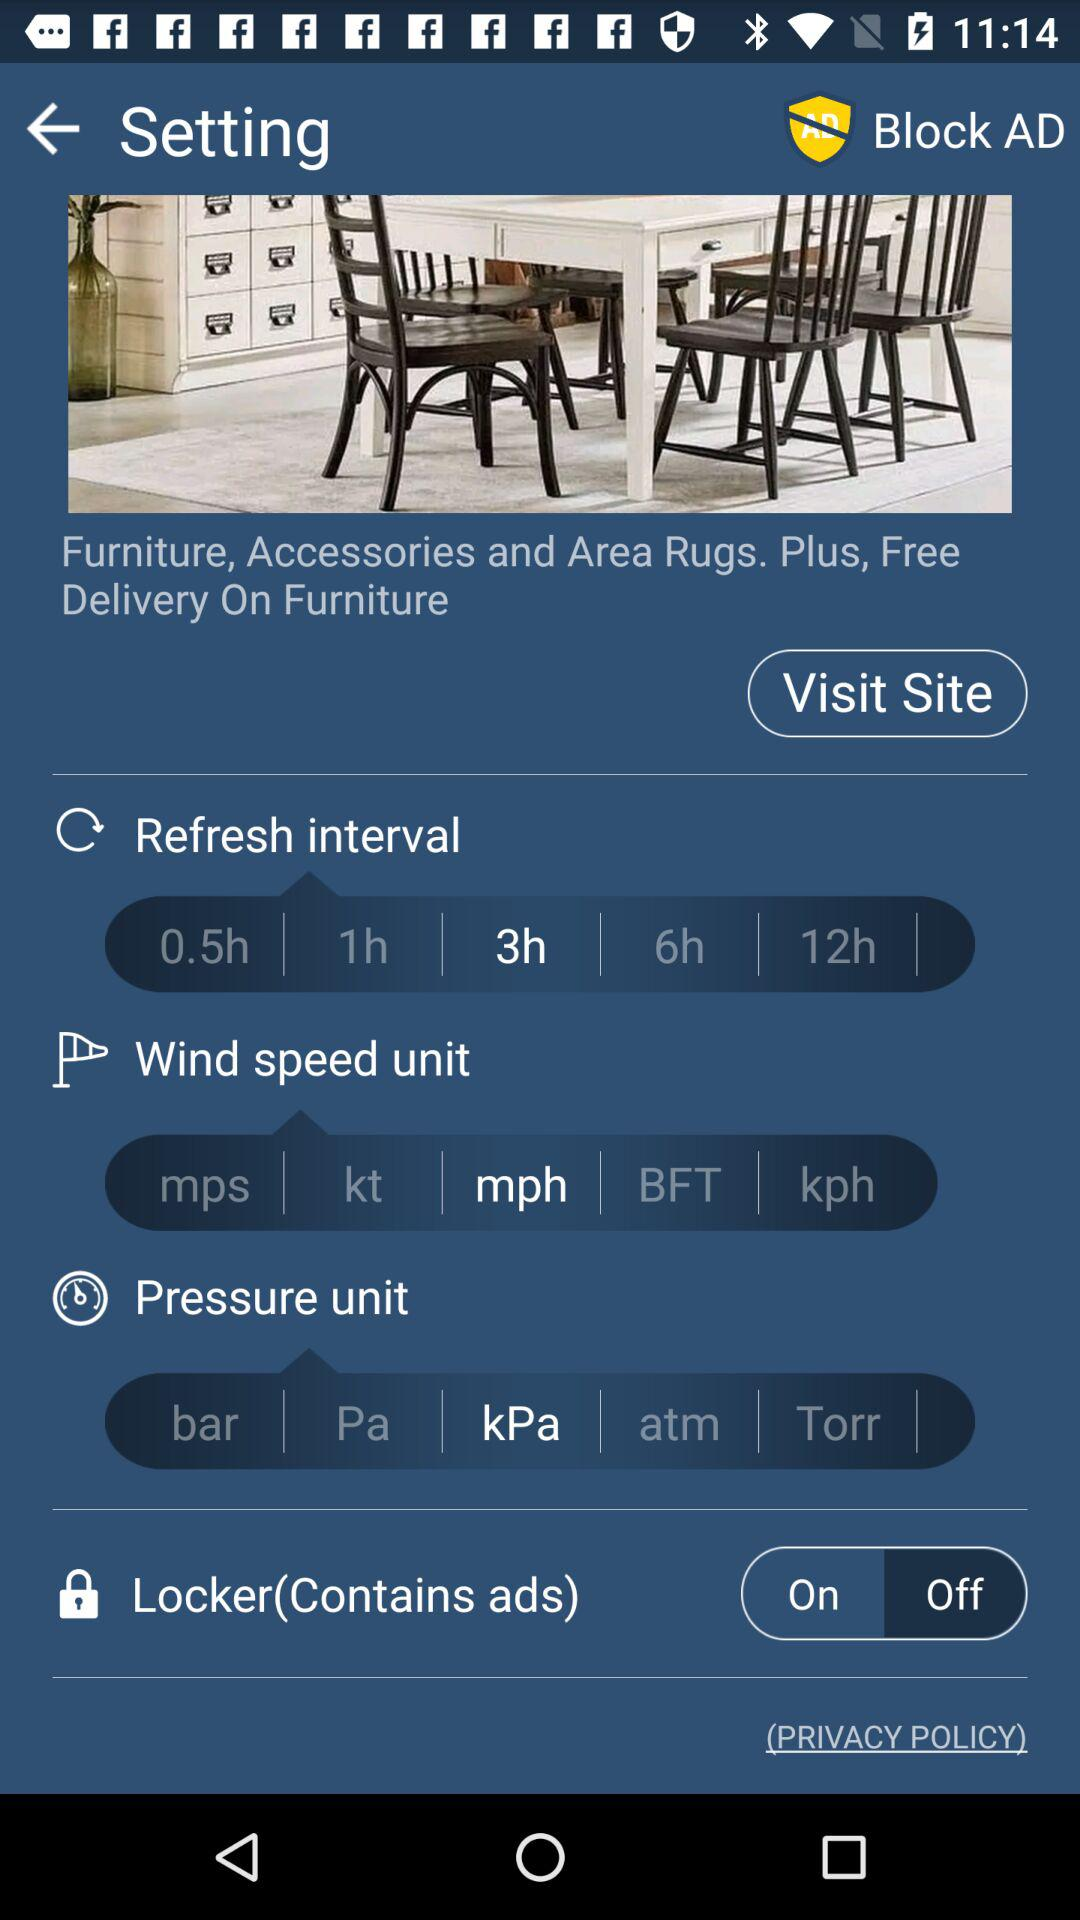What is the refresh interval timing selected? The selected refresh interval timing is 3 hours. 